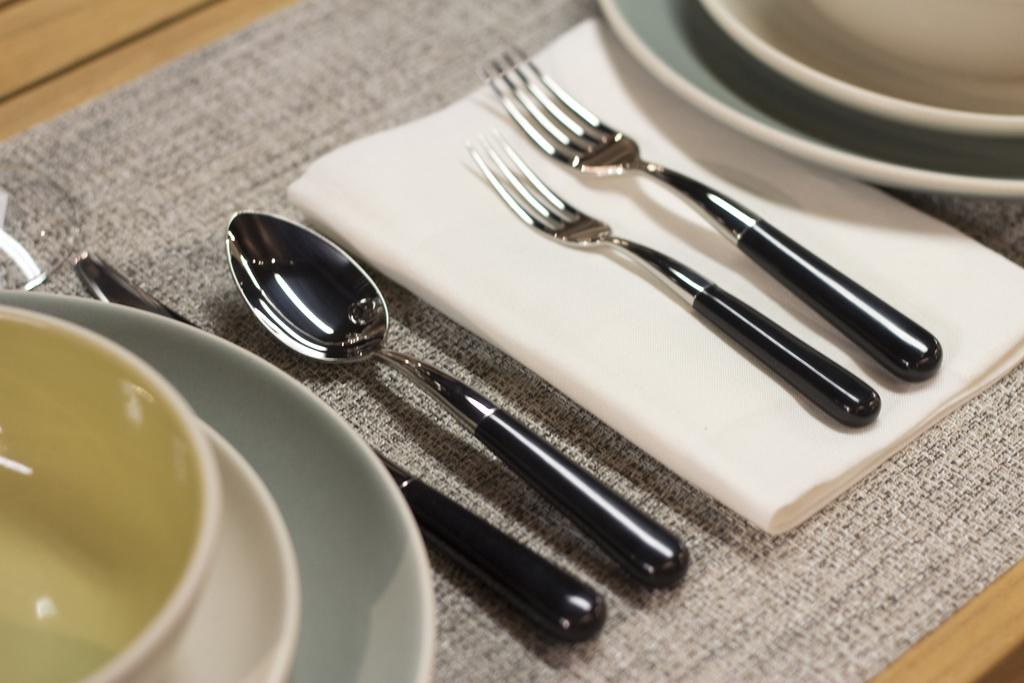What type of furniture is present in the image? There is a table in the image. What items can be seen on the table? Clothes, tissue papers, forks, spoons, bowls, and saucers are present on the table. How many types of utensils are on the table? There are two types of utensils on the table: forks and spoons. What other items are on the table that are not utensils? Clothes, tissue papers, bowls, and saucers are on the table. What type of chain can be seen around the ring on the table? There is no chain or ring present on the table in the image. 